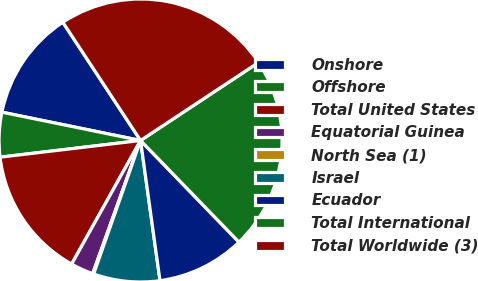Convert chart. <chart><loc_0><loc_0><loc_500><loc_500><pie_chart><fcel>Onshore<fcel>Offshore<fcel>Total United States<fcel>Equatorial Guinea<fcel>North Sea (1)<fcel>Israel<fcel>Ecuador<fcel>Total International<fcel>Total Worldwide (3)<nl><fcel>12.54%<fcel>5.09%<fcel>15.02%<fcel>2.6%<fcel>0.12%<fcel>7.57%<fcel>10.05%<fcel>22.06%<fcel>24.95%<nl></chart> 